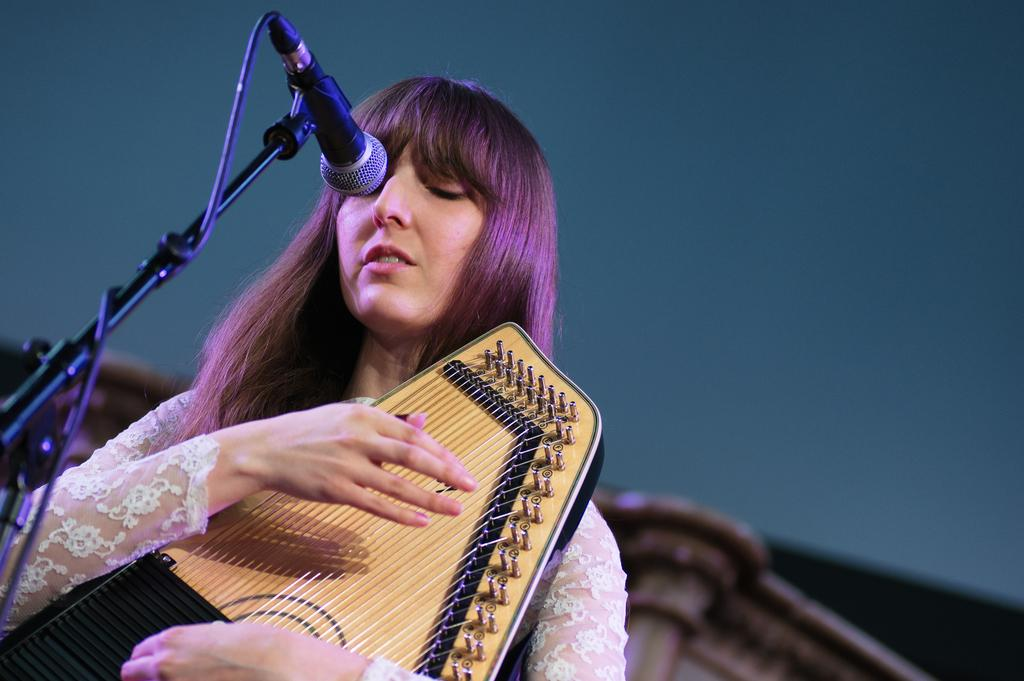What is the main subject of the image? The main subject of the image is a woman. What is the woman holding in the image? The woman is holding an object, likely a microphone. Can you confirm the presence of a microphone in the image? Yes, there is a microphone in the image. How many babies are wrapped in the quilt in the image? There is no quilt or babies present in the image; it features a woman holding a microphone. 